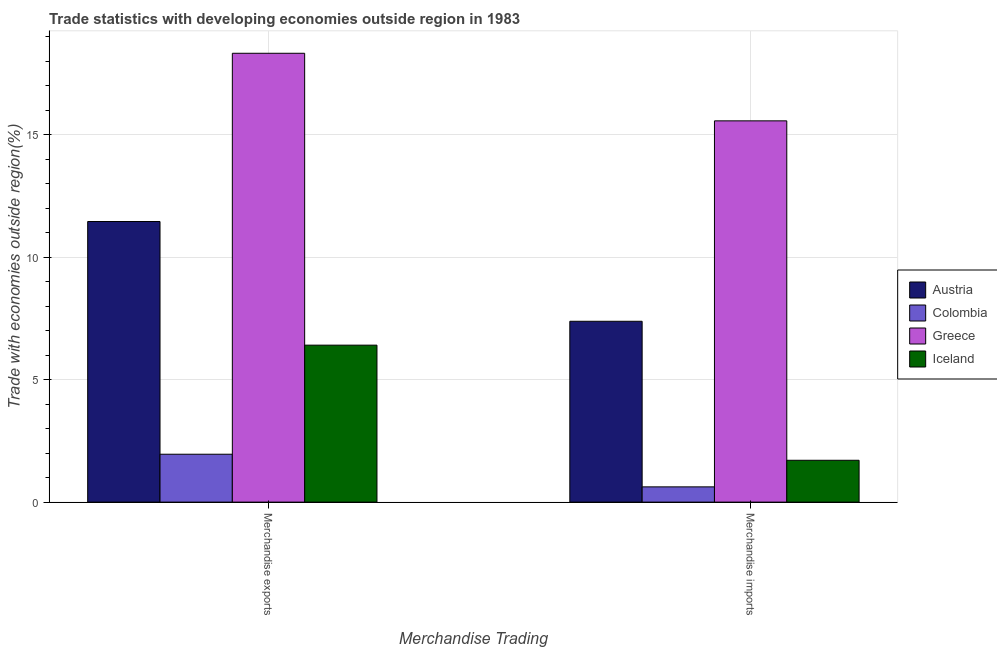Are the number of bars per tick equal to the number of legend labels?
Offer a terse response. Yes. How many bars are there on the 1st tick from the left?
Provide a succinct answer. 4. What is the merchandise imports in Iceland?
Keep it short and to the point. 1.71. Across all countries, what is the maximum merchandise imports?
Your response must be concise. 15.57. Across all countries, what is the minimum merchandise exports?
Provide a succinct answer. 1.96. In which country was the merchandise exports maximum?
Provide a short and direct response. Greece. In which country was the merchandise exports minimum?
Offer a terse response. Colombia. What is the total merchandise exports in the graph?
Offer a very short reply. 38.15. What is the difference between the merchandise exports in Iceland and that in Colombia?
Your response must be concise. 4.45. What is the difference between the merchandise imports in Greece and the merchandise exports in Austria?
Offer a very short reply. 4.11. What is the average merchandise imports per country?
Your answer should be compact. 6.32. What is the difference between the merchandise imports and merchandise exports in Greece?
Make the answer very short. -2.76. What is the ratio of the merchandise imports in Austria to that in Greece?
Offer a very short reply. 0.47. Is the merchandise exports in Austria less than that in Greece?
Keep it short and to the point. Yes. What does the 4th bar from the left in Merchandise imports represents?
Your response must be concise. Iceland. What does the 3rd bar from the right in Merchandise imports represents?
Make the answer very short. Colombia. How many bars are there?
Make the answer very short. 8. Are all the bars in the graph horizontal?
Give a very brief answer. No. What is the difference between two consecutive major ticks on the Y-axis?
Your response must be concise. 5. Are the values on the major ticks of Y-axis written in scientific E-notation?
Make the answer very short. No. Does the graph contain grids?
Provide a succinct answer. Yes. Where does the legend appear in the graph?
Keep it short and to the point. Center right. How many legend labels are there?
Give a very brief answer. 4. What is the title of the graph?
Keep it short and to the point. Trade statistics with developing economies outside region in 1983. Does "India" appear as one of the legend labels in the graph?
Your answer should be very brief. No. What is the label or title of the X-axis?
Ensure brevity in your answer.  Merchandise Trading. What is the label or title of the Y-axis?
Provide a succinct answer. Trade with economies outside region(%). What is the Trade with economies outside region(%) in Austria in Merchandise exports?
Offer a very short reply. 11.46. What is the Trade with economies outside region(%) of Colombia in Merchandise exports?
Make the answer very short. 1.96. What is the Trade with economies outside region(%) in Greece in Merchandise exports?
Offer a very short reply. 18.32. What is the Trade with economies outside region(%) in Iceland in Merchandise exports?
Keep it short and to the point. 6.41. What is the Trade with economies outside region(%) of Austria in Merchandise imports?
Provide a short and direct response. 7.38. What is the Trade with economies outside region(%) of Colombia in Merchandise imports?
Provide a short and direct response. 0.62. What is the Trade with economies outside region(%) in Greece in Merchandise imports?
Ensure brevity in your answer.  15.57. What is the Trade with economies outside region(%) of Iceland in Merchandise imports?
Your answer should be compact. 1.71. Across all Merchandise Trading, what is the maximum Trade with economies outside region(%) of Austria?
Your answer should be very brief. 11.46. Across all Merchandise Trading, what is the maximum Trade with economies outside region(%) of Colombia?
Your response must be concise. 1.96. Across all Merchandise Trading, what is the maximum Trade with economies outside region(%) in Greece?
Your answer should be compact. 18.32. Across all Merchandise Trading, what is the maximum Trade with economies outside region(%) of Iceland?
Offer a terse response. 6.41. Across all Merchandise Trading, what is the minimum Trade with economies outside region(%) of Austria?
Give a very brief answer. 7.38. Across all Merchandise Trading, what is the minimum Trade with economies outside region(%) in Colombia?
Ensure brevity in your answer.  0.62. Across all Merchandise Trading, what is the minimum Trade with economies outside region(%) of Greece?
Keep it short and to the point. 15.57. Across all Merchandise Trading, what is the minimum Trade with economies outside region(%) of Iceland?
Your response must be concise. 1.71. What is the total Trade with economies outside region(%) in Austria in the graph?
Offer a very short reply. 18.84. What is the total Trade with economies outside region(%) in Colombia in the graph?
Ensure brevity in your answer.  2.58. What is the total Trade with economies outside region(%) in Greece in the graph?
Give a very brief answer. 33.89. What is the total Trade with economies outside region(%) of Iceland in the graph?
Offer a very short reply. 8.12. What is the difference between the Trade with economies outside region(%) in Austria in Merchandise exports and that in Merchandise imports?
Your answer should be compact. 4.07. What is the difference between the Trade with economies outside region(%) of Colombia in Merchandise exports and that in Merchandise imports?
Your answer should be compact. 1.33. What is the difference between the Trade with economies outside region(%) of Greece in Merchandise exports and that in Merchandise imports?
Offer a very short reply. 2.76. What is the difference between the Trade with economies outside region(%) in Iceland in Merchandise exports and that in Merchandise imports?
Provide a succinct answer. 4.7. What is the difference between the Trade with economies outside region(%) in Austria in Merchandise exports and the Trade with economies outside region(%) in Colombia in Merchandise imports?
Your answer should be very brief. 10.83. What is the difference between the Trade with economies outside region(%) in Austria in Merchandise exports and the Trade with economies outside region(%) in Greece in Merchandise imports?
Give a very brief answer. -4.11. What is the difference between the Trade with economies outside region(%) of Austria in Merchandise exports and the Trade with economies outside region(%) of Iceland in Merchandise imports?
Provide a short and direct response. 9.75. What is the difference between the Trade with economies outside region(%) of Colombia in Merchandise exports and the Trade with economies outside region(%) of Greece in Merchandise imports?
Your answer should be very brief. -13.61. What is the difference between the Trade with economies outside region(%) of Colombia in Merchandise exports and the Trade with economies outside region(%) of Iceland in Merchandise imports?
Ensure brevity in your answer.  0.25. What is the difference between the Trade with economies outside region(%) of Greece in Merchandise exports and the Trade with economies outside region(%) of Iceland in Merchandise imports?
Your answer should be compact. 16.62. What is the average Trade with economies outside region(%) of Austria per Merchandise Trading?
Your answer should be compact. 9.42. What is the average Trade with economies outside region(%) in Colombia per Merchandise Trading?
Offer a terse response. 1.29. What is the average Trade with economies outside region(%) of Greece per Merchandise Trading?
Make the answer very short. 16.95. What is the average Trade with economies outside region(%) in Iceland per Merchandise Trading?
Provide a succinct answer. 4.06. What is the difference between the Trade with economies outside region(%) in Austria and Trade with economies outside region(%) in Colombia in Merchandise exports?
Your answer should be very brief. 9.5. What is the difference between the Trade with economies outside region(%) in Austria and Trade with economies outside region(%) in Greece in Merchandise exports?
Your answer should be compact. -6.87. What is the difference between the Trade with economies outside region(%) in Austria and Trade with economies outside region(%) in Iceland in Merchandise exports?
Your response must be concise. 5.05. What is the difference between the Trade with economies outside region(%) in Colombia and Trade with economies outside region(%) in Greece in Merchandise exports?
Offer a terse response. -16.37. What is the difference between the Trade with economies outside region(%) in Colombia and Trade with economies outside region(%) in Iceland in Merchandise exports?
Your answer should be compact. -4.45. What is the difference between the Trade with economies outside region(%) of Greece and Trade with economies outside region(%) of Iceland in Merchandise exports?
Offer a terse response. 11.92. What is the difference between the Trade with economies outside region(%) in Austria and Trade with economies outside region(%) in Colombia in Merchandise imports?
Keep it short and to the point. 6.76. What is the difference between the Trade with economies outside region(%) in Austria and Trade with economies outside region(%) in Greece in Merchandise imports?
Your answer should be very brief. -8.18. What is the difference between the Trade with economies outside region(%) in Austria and Trade with economies outside region(%) in Iceland in Merchandise imports?
Provide a succinct answer. 5.67. What is the difference between the Trade with economies outside region(%) of Colombia and Trade with economies outside region(%) of Greece in Merchandise imports?
Ensure brevity in your answer.  -14.94. What is the difference between the Trade with economies outside region(%) in Colombia and Trade with economies outside region(%) in Iceland in Merchandise imports?
Your answer should be very brief. -1.09. What is the difference between the Trade with economies outside region(%) of Greece and Trade with economies outside region(%) of Iceland in Merchandise imports?
Provide a succinct answer. 13.86. What is the ratio of the Trade with economies outside region(%) in Austria in Merchandise exports to that in Merchandise imports?
Your answer should be compact. 1.55. What is the ratio of the Trade with economies outside region(%) in Colombia in Merchandise exports to that in Merchandise imports?
Your response must be concise. 3.14. What is the ratio of the Trade with economies outside region(%) of Greece in Merchandise exports to that in Merchandise imports?
Provide a succinct answer. 1.18. What is the ratio of the Trade with economies outside region(%) of Iceland in Merchandise exports to that in Merchandise imports?
Make the answer very short. 3.75. What is the difference between the highest and the second highest Trade with economies outside region(%) in Austria?
Your answer should be very brief. 4.07. What is the difference between the highest and the second highest Trade with economies outside region(%) of Colombia?
Make the answer very short. 1.33. What is the difference between the highest and the second highest Trade with economies outside region(%) of Greece?
Keep it short and to the point. 2.76. What is the difference between the highest and the second highest Trade with economies outside region(%) in Iceland?
Provide a succinct answer. 4.7. What is the difference between the highest and the lowest Trade with economies outside region(%) in Austria?
Keep it short and to the point. 4.07. What is the difference between the highest and the lowest Trade with economies outside region(%) in Colombia?
Keep it short and to the point. 1.33. What is the difference between the highest and the lowest Trade with economies outside region(%) of Greece?
Keep it short and to the point. 2.76. What is the difference between the highest and the lowest Trade with economies outside region(%) in Iceland?
Provide a short and direct response. 4.7. 